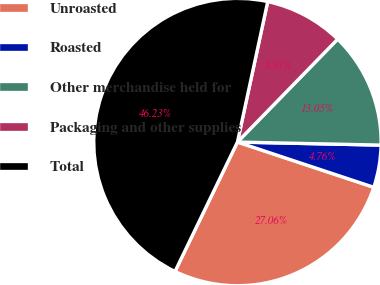Convert chart. <chart><loc_0><loc_0><loc_500><loc_500><pie_chart><fcel>Unroasted<fcel>Roasted<fcel>Other merchandise held for<fcel>Packaging and other supplies<fcel>Total<nl><fcel>27.06%<fcel>4.76%<fcel>13.05%<fcel>8.91%<fcel>46.23%<nl></chart> 